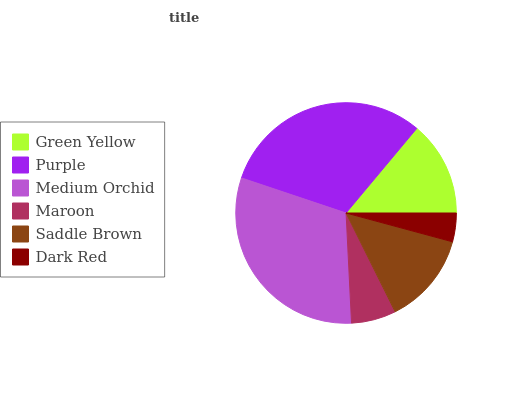Is Dark Red the minimum?
Answer yes or no. Yes. Is Purple the maximum?
Answer yes or no. Yes. Is Medium Orchid the minimum?
Answer yes or no. No. Is Medium Orchid the maximum?
Answer yes or no. No. Is Purple greater than Medium Orchid?
Answer yes or no. Yes. Is Medium Orchid less than Purple?
Answer yes or no. Yes. Is Medium Orchid greater than Purple?
Answer yes or no. No. Is Purple less than Medium Orchid?
Answer yes or no. No. Is Green Yellow the high median?
Answer yes or no. Yes. Is Saddle Brown the low median?
Answer yes or no. Yes. Is Medium Orchid the high median?
Answer yes or no. No. Is Medium Orchid the low median?
Answer yes or no. No. 